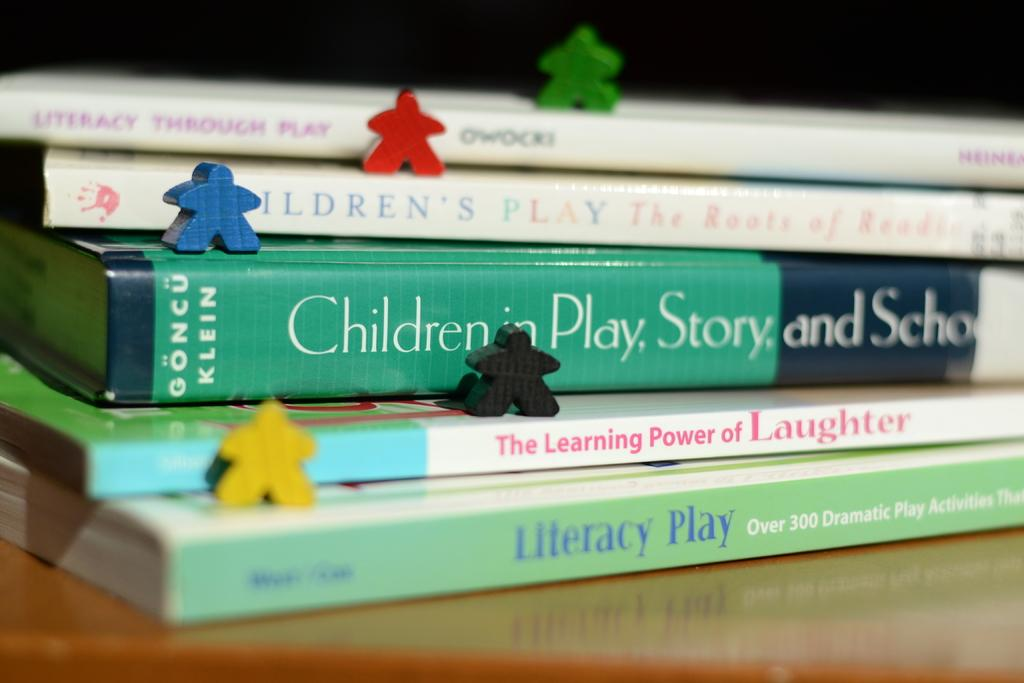Provide a one-sentence caption for the provided image. a few books that have literacy written on one. 